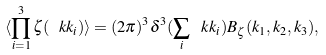<formula> <loc_0><loc_0><loc_500><loc_500>\langle \prod _ { i = 1 } ^ { 3 } \zeta ( \ k k _ { i } ) \rangle = ( 2 \pi ) ^ { 3 } \delta ^ { 3 } ( \sum _ { i } \ k k _ { i } ) B _ { \zeta } ( k _ { 1 } , k _ { 2 } , k _ { 3 } ) ,</formula> 